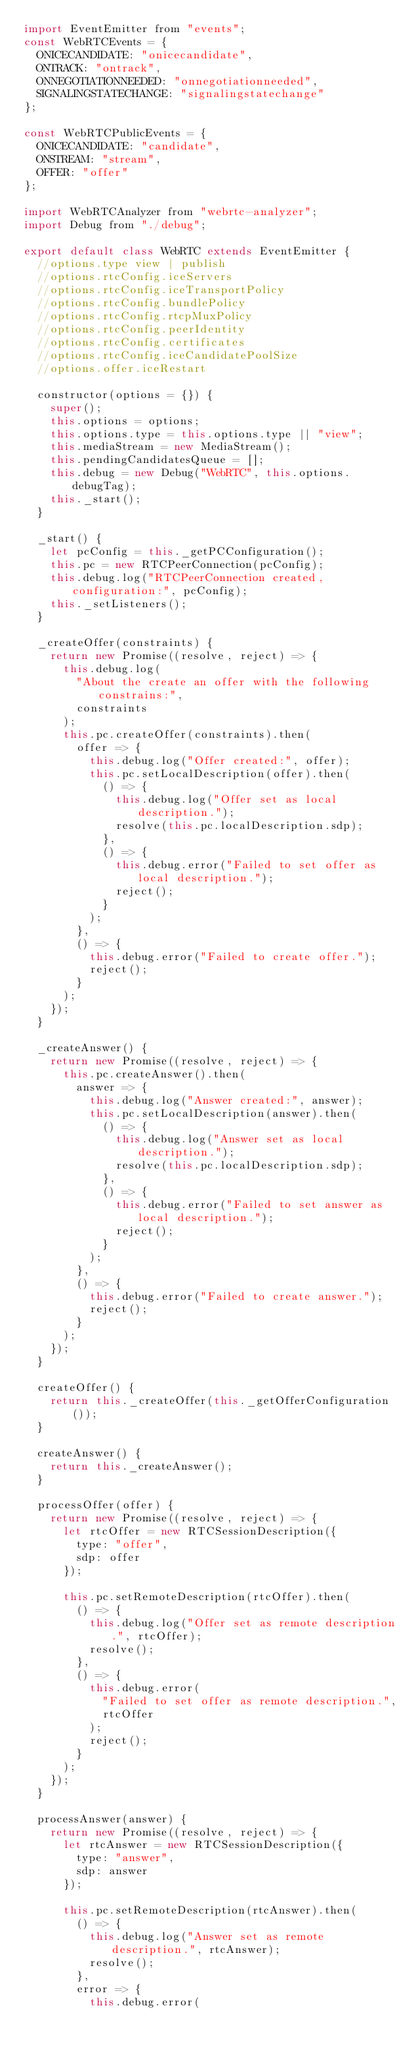<code> <loc_0><loc_0><loc_500><loc_500><_JavaScript_>import EventEmitter from "events";
const WebRTCEvents = {
  ONICECANDIDATE: "onicecandidate",
  ONTRACK: "ontrack",
  ONNEGOTIATIONNEEDED: "onnegotiationneeded",
  SIGNALINGSTATECHANGE: "signalingstatechange"
};

const WebRTCPublicEvents = {
  ONICECANDIDATE: "candidate",
  ONSTREAM: "stream",
  OFFER: "offer"
};

import WebRTCAnalyzer from "webrtc-analyzer";
import Debug from "./debug";

export default class WebRTC extends EventEmitter {
  //options.type view | publish
  //options.rtcConfig.iceServers
  //options.rtcConfig.iceTransportPolicy
  //options.rtcConfig.bundlePolicy
  //options.rtcConfig.rtcpMuxPolicy
  //options.rtcConfig.peerIdentity
  //options.rtcConfig.certificates
  //options.rtcConfig.iceCandidatePoolSize
  //options.offer.iceRestart

  constructor(options = {}) {
    super();
    this.options = options;
    this.options.type = this.options.type || "view";
    this.mediaStream = new MediaStream();
    this.pendingCandidatesQueue = [];
    this.debug = new Debug("WebRTC", this.options.debugTag);
    this._start();
  }

  _start() {
    let pcConfig = this._getPCConfiguration();
    this.pc = new RTCPeerConnection(pcConfig);
    this.debug.log("RTCPeerConnection created, configuration:", pcConfig);
    this._setListeners();
  }

  _createOffer(constraints) {
    return new Promise((resolve, reject) => {
      this.debug.log(
        "About the create an offer with the following constrains:",
        constraints
      );
      this.pc.createOffer(constraints).then(
        offer => {
          this.debug.log("Offer created:", offer);
          this.pc.setLocalDescription(offer).then(
            () => {
              this.debug.log("Offer set as local description.");
              resolve(this.pc.localDescription.sdp);
            },
            () => {
              this.debug.error("Failed to set offer as local description.");
              reject();
            }
          );
        },
        () => {
          this.debug.error("Failed to create offer.");
          reject();
        }
      );
    });
  }

  _createAnswer() {
    return new Promise((resolve, reject) => {
      this.pc.createAnswer().then(
        answer => {
          this.debug.log("Answer created:", answer);
          this.pc.setLocalDescription(answer).then(
            () => {
              this.debug.log("Answer set as local description.");
              resolve(this.pc.localDescription.sdp);
            },
            () => {
              this.debug.error("Failed to set answer as local description.");
              reject();
            }
          );
        },
        () => {
          this.debug.error("Failed to create answer.");
          reject();
        }
      );
    });
  }

  createOffer() {
    return this._createOffer(this._getOfferConfiguration());
  }

  createAnswer() {
    return this._createAnswer();
  }

  processOffer(offer) {
    return new Promise((resolve, reject) => {
      let rtcOffer = new RTCSessionDescription({
        type: "offer",
        sdp: offer
      });

      this.pc.setRemoteDescription(rtcOffer).then(
        () => {
          this.debug.log("Offer set as remote description.", rtcOffer);
          resolve();
        },
        () => {
          this.debug.error(
            "Failed to set offer as remote description.",
            rtcOffer
          );
          reject();
        }
      );
    });
  }

  processAnswer(answer) {
    return new Promise((resolve, reject) => {
      let rtcAnswer = new RTCSessionDescription({
        type: "answer",
        sdp: answer
      });

      this.pc.setRemoteDescription(rtcAnswer).then(
        () => {
          this.debug.log("Answer set as remote description.", rtcAnswer);
          resolve();
        },
        error => {
          this.debug.error(</code> 